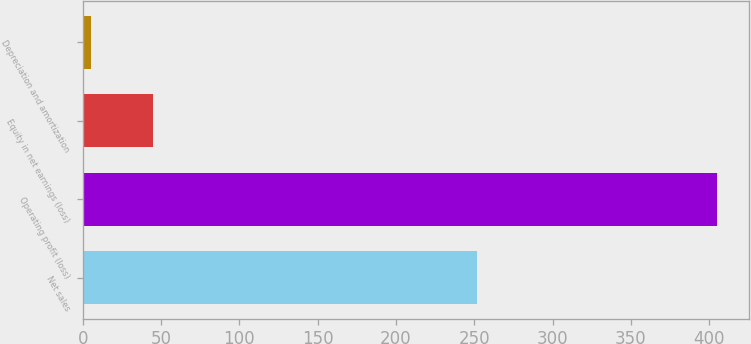Convert chart to OTSL. <chart><loc_0><loc_0><loc_500><loc_500><bar_chart><fcel>Net sales<fcel>Operating profit (loss)<fcel>Equity in net earnings (loss)<fcel>Depreciation and amortization<nl><fcel>252<fcel>405<fcel>45<fcel>5<nl></chart> 